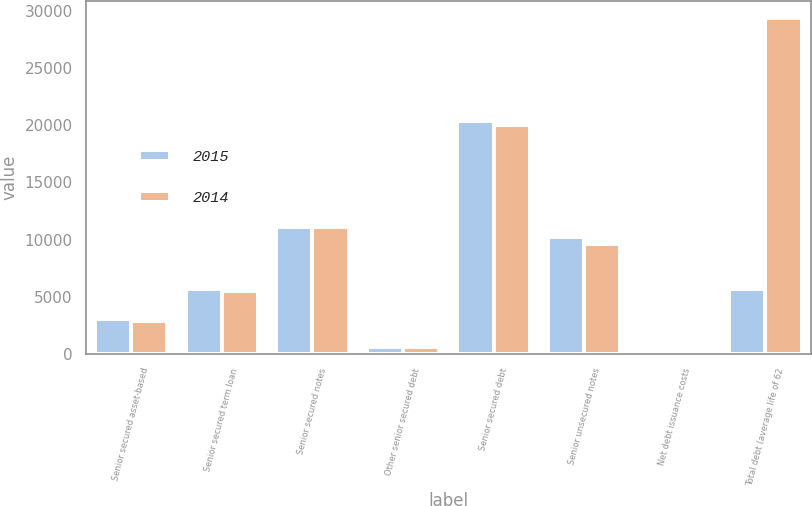<chart> <loc_0><loc_0><loc_500><loc_500><stacked_bar_chart><ecel><fcel>Senior secured asset-based<fcel>Senior secured term loan<fcel>Senior secured notes<fcel>Other senior secured debt<fcel>Senior secured debt<fcel>Senior unsecured notes<fcel>Net debt issuance costs<fcel>Total debt (average life of 62<nl><fcel>2015<fcel>3030<fcel>5639<fcel>11100<fcel>634<fcel>20403<fcel>10252<fcel>167<fcel>5639<nl><fcel>2014<fcel>2880<fcel>5517<fcel>11100<fcel>573<fcel>20070<fcel>9575<fcel>219<fcel>29426<nl></chart> 